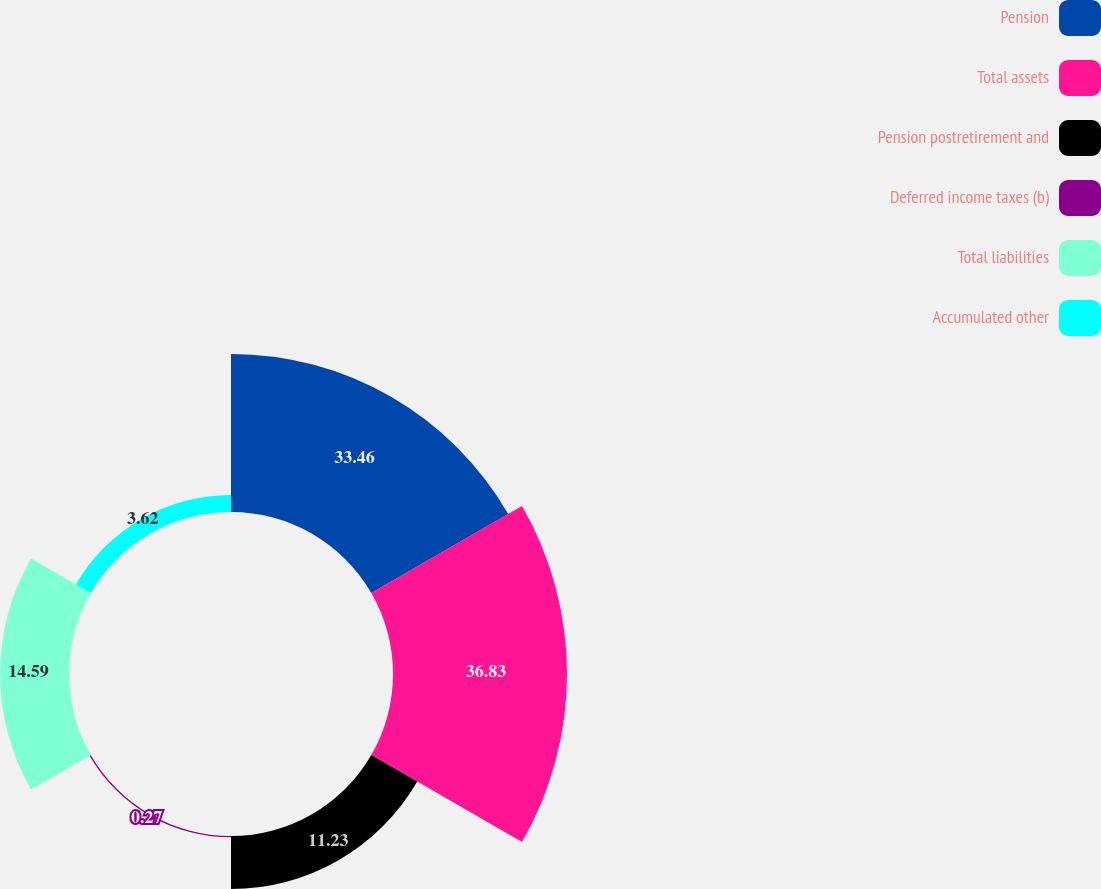Convert chart to OTSL. <chart><loc_0><loc_0><loc_500><loc_500><pie_chart><fcel>Pension<fcel>Total assets<fcel>Pension postretirement and<fcel>Deferred income taxes (b)<fcel>Total liabilities<fcel>Accumulated other<nl><fcel>33.46%<fcel>36.82%<fcel>11.23%<fcel>0.27%<fcel>14.59%<fcel>3.62%<nl></chart> 